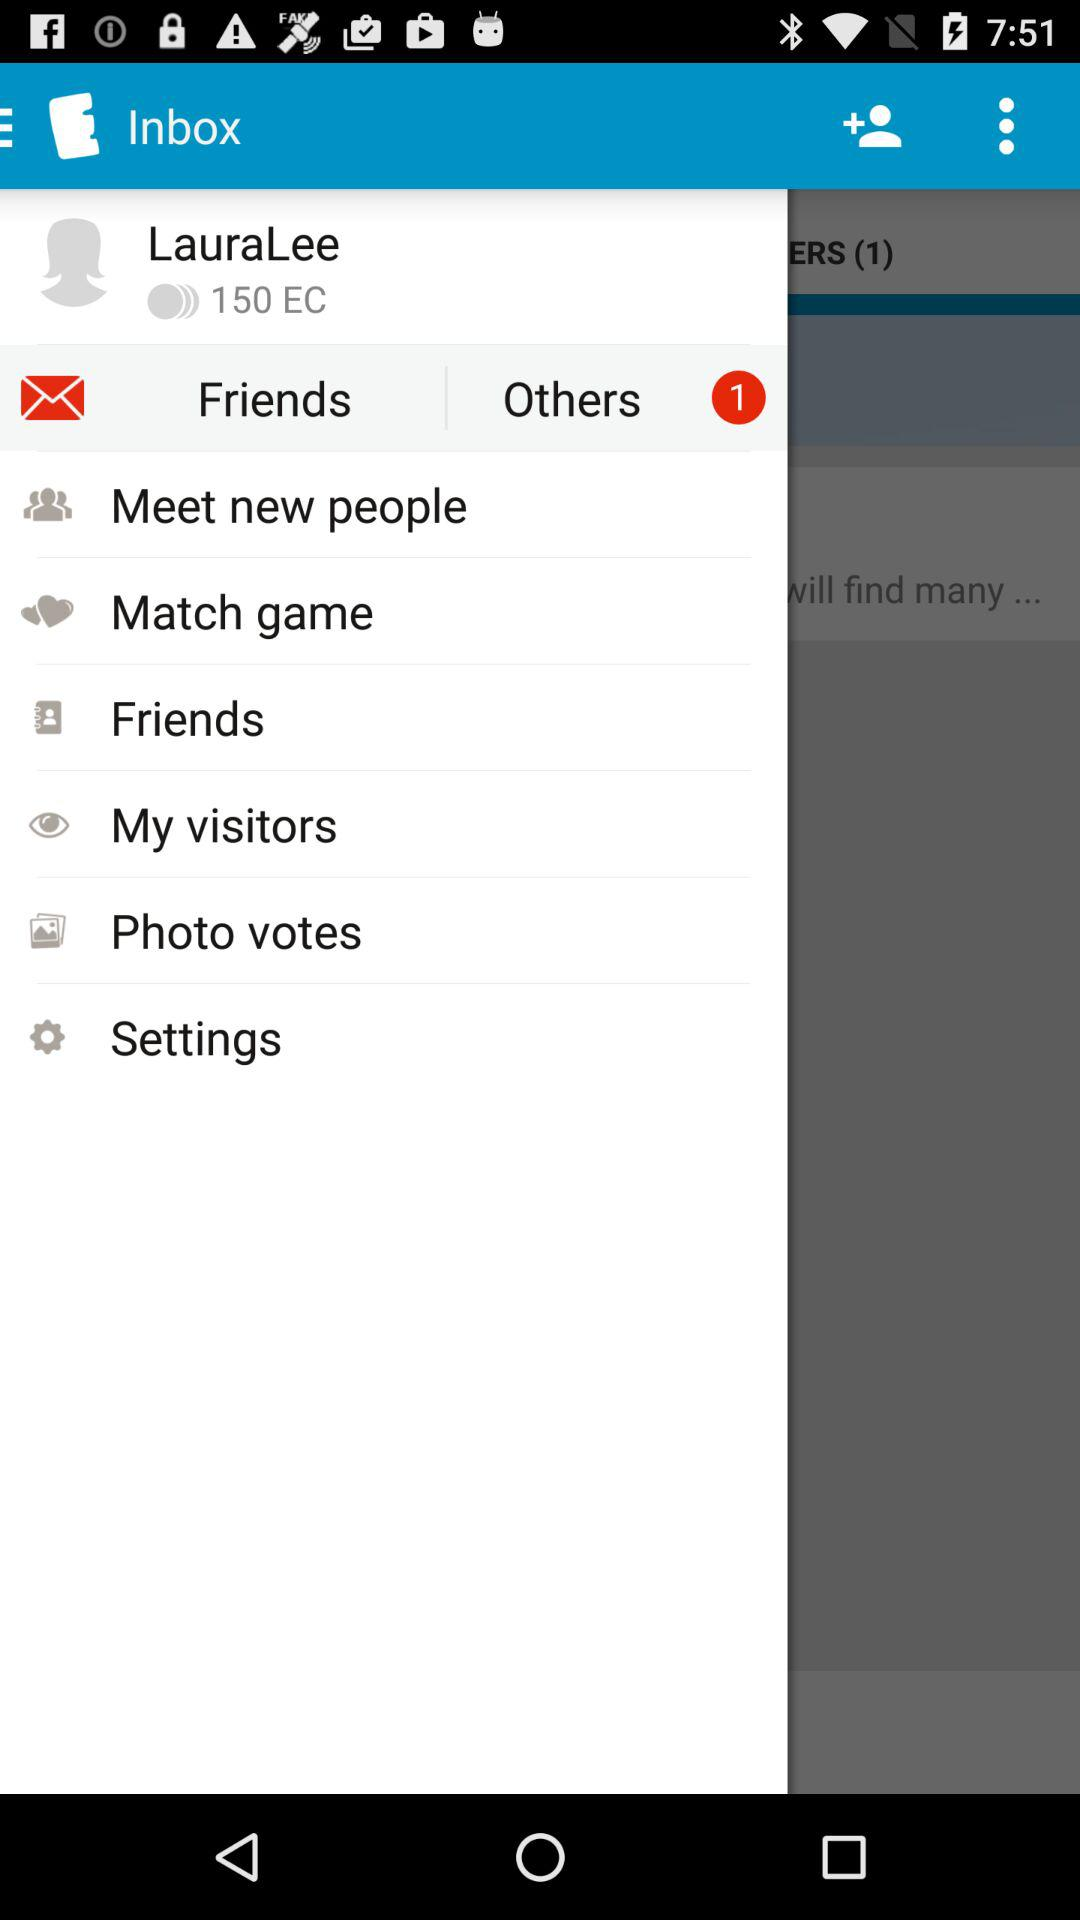How many notifications are there in "Others"? There is 1 notification. 